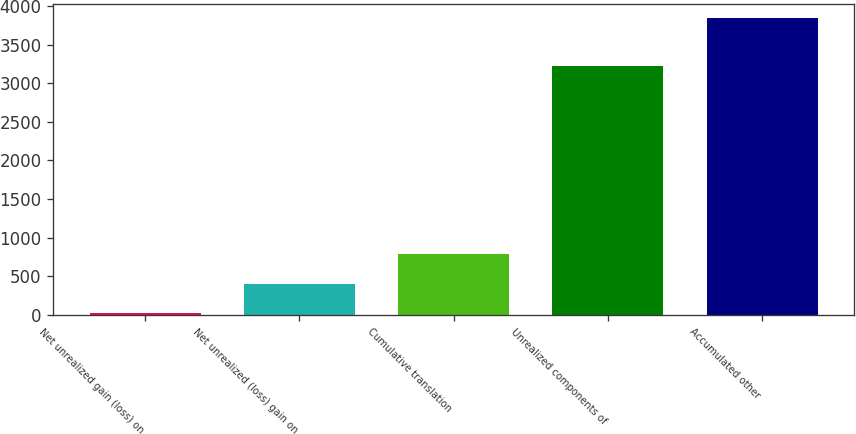<chart> <loc_0><loc_0><loc_500><loc_500><bar_chart><fcel>Net unrealized gain (loss) on<fcel>Net unrealized (loss) gain on<fcel>Cumulative translation<fcel>Unrealized components of<fcel>Accumulated other<nl><fcel>20<fcel>401.7<fcel>783.4<fcel>3225<fcel>3837<nl></chart> 